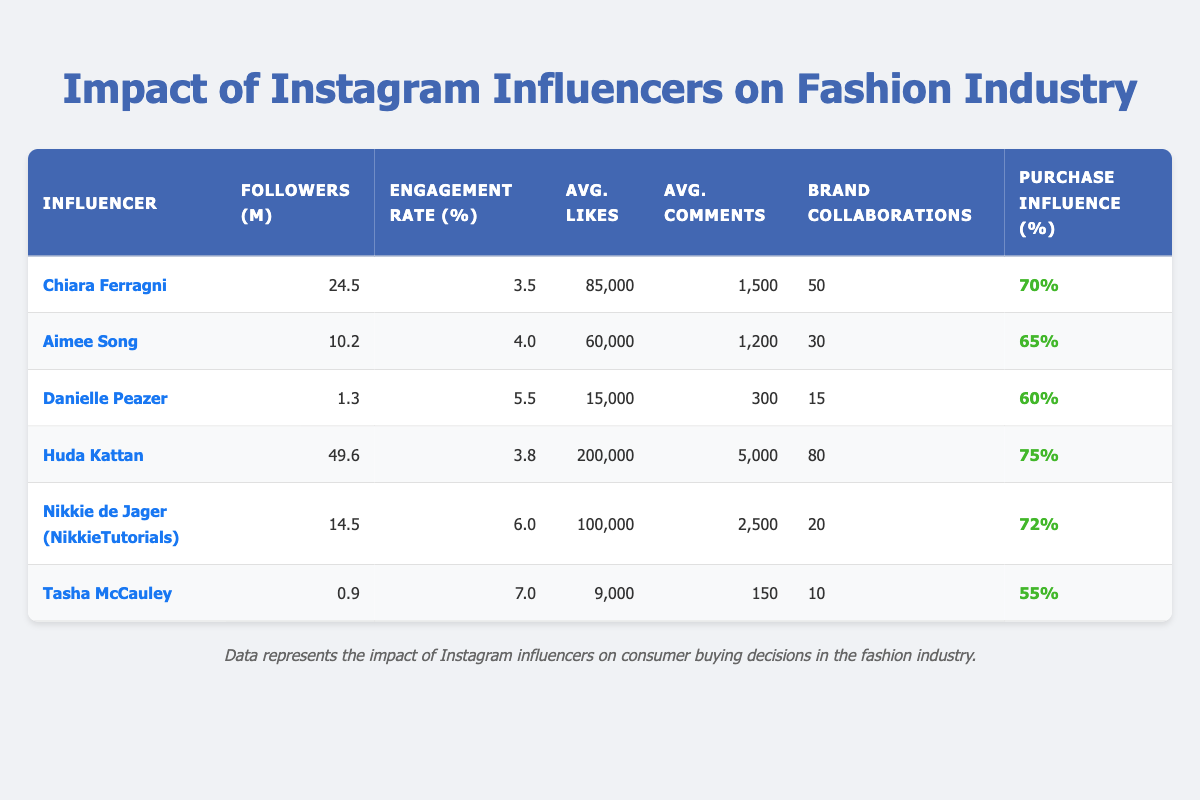What is the engagement rate of Huda Kattan? The table shows Huda Kattan's engagement rate listed in the corresponding column. It is stated as 3.8%.
Answer: 3.8% Who has the highest average likes among the influencers? By checking the "Avg. Likes" column, Huda Kattan has the highest average likes at 200,000.
Answer: Huda Kattan What percentage of followers does Danielle Peazer influence to purchase? The table indicates that Danielle Peazer has a purchase influence percentage of 60%.
Answer: 60% How many brand collaborations does Chiara Ferragni have compared to Tasha McCauley? Chiara Ferragni has 50 brand collaborations, and Tasha McCauley has 10. Comparing them, Chiara has 40 more collaborations than Tasha.
Answer: Chiara Ferragni has 40 more What is the average engagement rate of all influencers listed? To find the average engagement rate, sum the individual rates: 3.5 + 4.0 + 5.5 + 3.8 + 6.0 + 7.0 = 29.8. There are six influencers, so 29.8 / 6 = 4.97%.
Answer: 4.97% Which influencer has the lowest purchase influence percentage? By comparing the "Purchase Influence (%)" column, Tasha McCauley has the lowest purchase influence at 55%.
Answer: Tasha McCauley How many followers do the influencers collectively have? The total number of followers is found by adding each influencer's followers: 24.5 + 10.2 + 1.3 + 49.6 + 14.5 + 0.9 = 100.0 million.
Answer: 100.0 million Is it true that Nikkie de Jager has more followers than Chiara Ferragni? Comparing the followers, Nikkie de Jager has 14.5 million while Chiara Ferragni has 24.5 million. Thus, Nikkie does not have more followers.
Answer: False Which influencer shows the highest purchase influence percentage, and how much is it? Huda Kattan has the highest purchase influence percentage listed at 75%.
Answer: Huda Kattan, 75% If we consider influencers with engagement rates above 5%, how many brand collaborations do they have altogether? The influencers with engagement rates above 5% are Danielle Peazer (15), Nikkie de Jager (20), and Tasha McCauley (10). Total collaborations = 15 + 20 + 10 = 45.
Answer: 45 What average number of likes do influencers with over 10 million followers receive? The influencers with over 10 million followers are Chiara Ferragni, Aimee Song, Huda Kattan, and Nikkie de Jager. Their average likes calculation is (85,000 + 60,000 + 200,000 + 100,000) / 4 = 86,250.
Answer: 86,250 